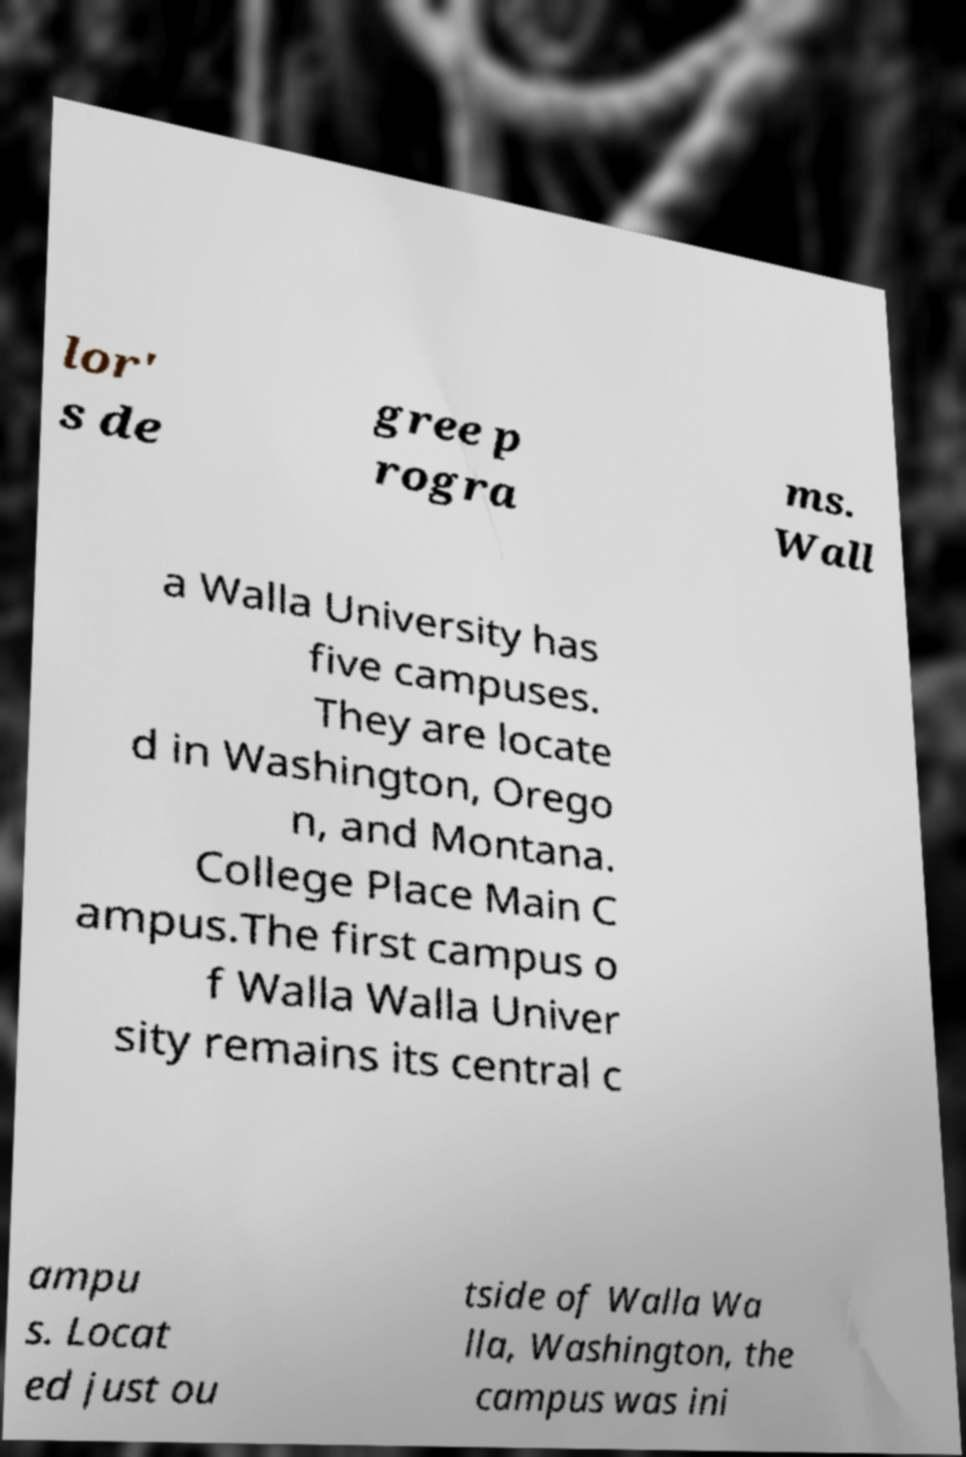For documentation purposes, I need the text within this image transcribed. Could you provide that? lor' s de gree p rogra ms. Wall a Walla University has five campuses. They are locate d in Washington, Orego n, and Montana. College Place Main C ampus.The first campus o f Walla Walla Univer sity remains its central c ampu s. Locat ed just ou tside of Walla Wa lla, Washington, the campus was ini 